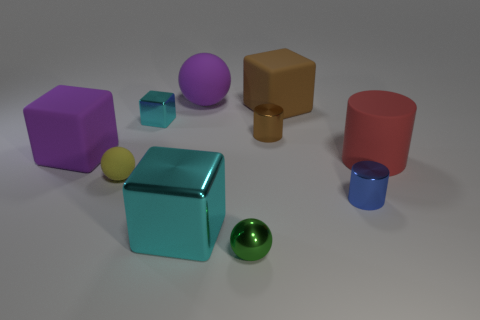How many things are large red rubber objects or green matte spheres?
Offer a terse response. 1. Is the size of the green sphere the same as the metal object that is on the right side of the small brown thing?
Make the answer very short. Yes. What number of other things are there of the same material as the brown block
Provide a short and direct response. 4. What number of objects are either small metal objects behind the large purple cube or large cubes behind the large cylinder?
Ensure brevity in your answer.  4. What material is the other big thing that is the same shape as the yellow matte thing?
Your response must be concise. Rubber. Is there a metallic cube?
Your response must be concise. Yes. What size is the rubber object that is both in front of the big brown block and to the right of the small metal ball?
Your answer should be very brief. Large. The large cyan object is what shape?
Ensure brevity in your answer.  Cube. Are there any matte objects that are left of the cyan metallic thing in front of the red object?
Ensure brevity in your answer.  Yes. There is a yellow ball that is the same size as the brown metal object; what material is it?
Ensure brevity in your answer.  Rubber. 